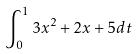Convert formula to latex. <formula><loc_0><loc_0><loc_500><loc_500>\int _ { 0 } ^ { 1 } 3 x ^ { 2 } + 2 x + 5 d t</formula> 